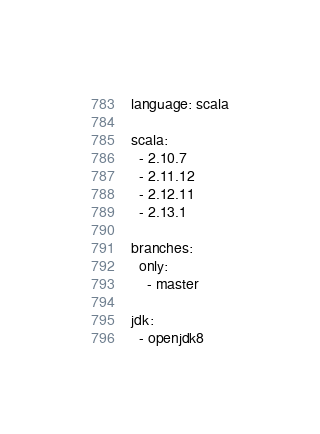Convert code to text. <code><loc_0><loc_0><loc_500><loc_500><_YAML_>language: scala

scala:
  - 2.10.7
  - 2.11.12
  - 2.12.11
  - 2.13.1

branches:
  only:
    - master

jdk:
  - openjdk8
</code> 